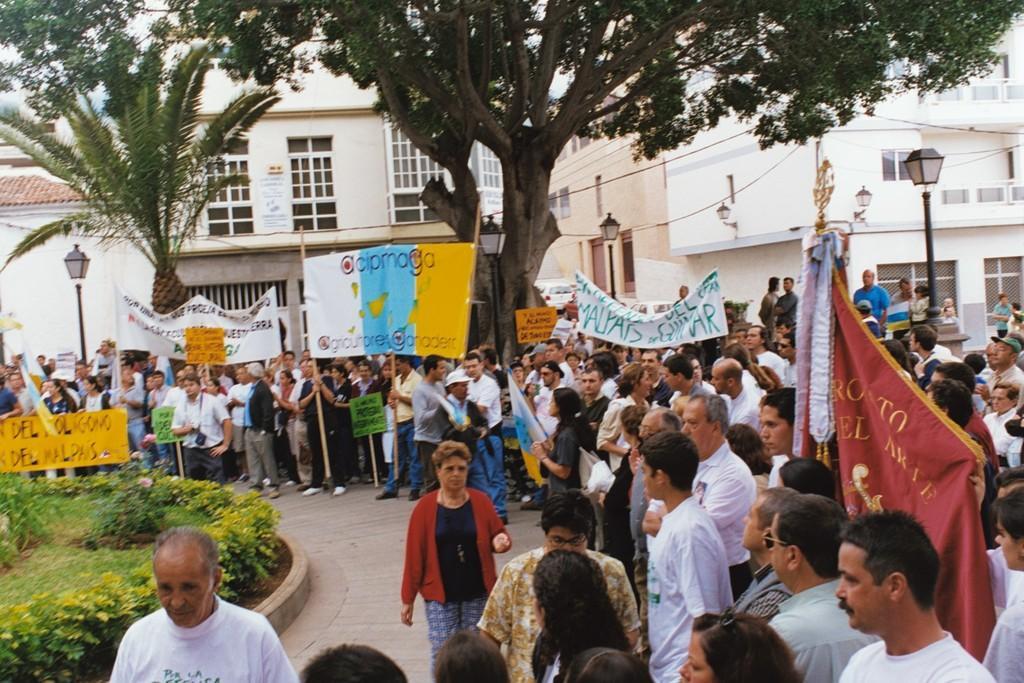Please provide a concise description of this image. In this image there are few people on the road holding banners and placards, there are street lights, buildings, trees and garden plants. 